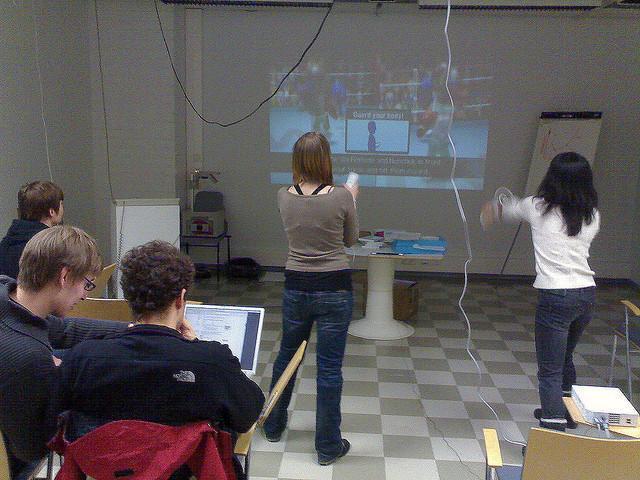How many chairs are there?
Give a very brief answer. 2. How many people are there?
Give a very brief answer. 5. 